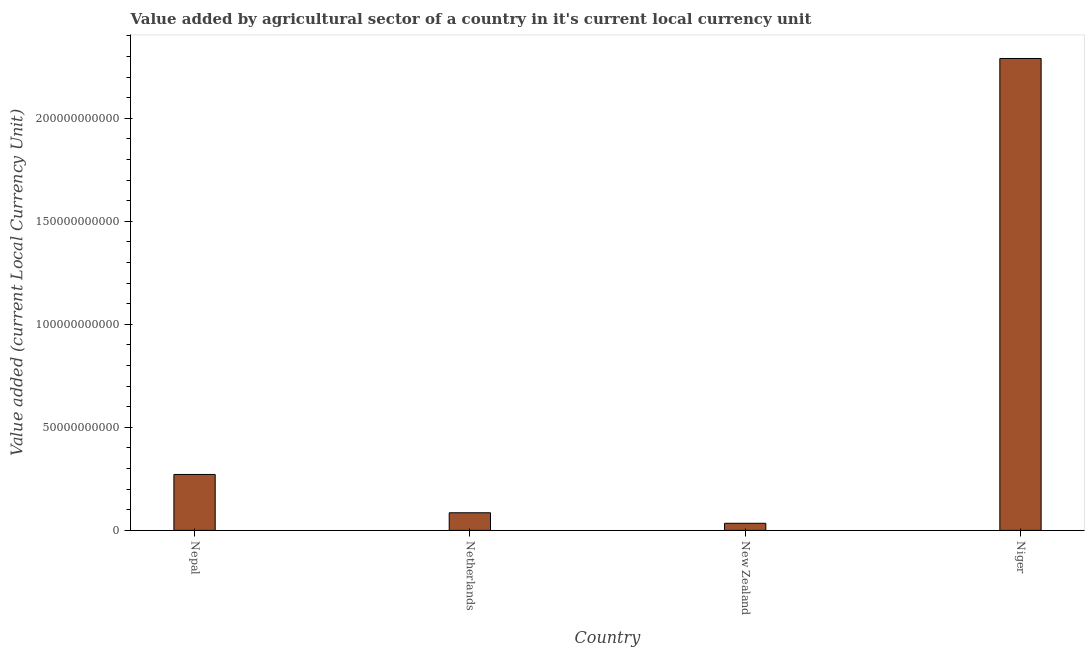Does the graph contain grids?
Offer a very short reply. No. What is the title of the graph?
Ensure brevity in your answer.  Value added by agricultural sector of a country in it's current local currency unit. What is the label or title of the Y-axis?
Provide a succinct answer. Value added (current Local Currency Unit). What is the value added by agriculture sector in Netherlands?
Offer a very short reply. 8.55e+09. Across all countries, what is the maximum value added by agriculture sector?
Provide a succinct answer. 2.29e+11. Across all countries, what is the minimum value added by agriculture sector?
Offer a very short reply. 3.45e+09. In which country was the value added by agriculture sector maximum?
Keep it short and to the point. Niger. In which country was the value added by agriculture sector minimum?
Your response must be concise. New Zealand. What is the sum of the value added by agriculture sector?
Provide a short and direct response. 2.68e+11. What is the difference between the value added by agriculture sector in Netherlands and Niger?
Provide a short and direct response. -2.20e+11. What is the average value added by agriculture sector per country?
Make the answer very short. 6.70e+1. What is the median value added by agriculture sector?
Provide a succinct answer. 1.78e+1. What is the ratio of the value added by agriculture sector in New Zealand to that in Niger?
Your answer should be compact. 0.01. Is the value added by agriculture sector in Nepal less than that in Niger?
Your answer should be very brief. Yes. Is the difference between the value added by agriculture sector in Netherlands and New Zealand greater than the difference between any two countries?
Provide a short and direct response. No. What is the difference between the highest and the second highest value added by agriculture sector?
Ensure brevity in your answer.  2.02e+11. What is the difference between the highest and the lowest value added by agriculture sector?
Your answer should be very brief. 2.26e+11. How many countries are there in the graph?
Provide a succinct answer. 4. What is the difference between two consecutive major ticks on the Y-axis?
Your answer should be very brief. 5.00e+1. Are the values on the major ticks of Y-axis written in scientific E-notation?
Provide a short and direct response. No. What is the Value added (current Local Currency Unit) of Nepal?
Offer a very short reply. 2.71e+1. What is the Value added (current Local Currency Unit) in Netherlands?
Your answer should be compact. 8.55e+09. What is the Value added (current Local Currency Unit) of New Zealand?
Your answer should be very brief. 3.45e+09. What is the Value added (current Local Currency Unit) in Niger?
Ensure brevity in your answer.  2.29e+11. What is the difference between the Value added (current Local Currency Unit) in Nepal and Netherlands?
Keep it short and to the point. 1.86e+1. What is the difference between the Value added (current Local Currency Unit) in Nepal and New Zealand?
Offer a very short reply. 2.37e+1. What is the difference between the Value added (current Local Currency Unit) in Nepal and Niger?
Provide a succinct answer. -2.02e+11. What is the difference between the Value added (current Local Currency Unit) in Netherlands and New Zealand?
Your answer should be compact. 5.10e+09. What is the difference between the Value added (current Local Currency Unit) in Netherlands and Niger?
Ensure brevity in your answer.  -2.20e+11. What is the difference between the Value added (current Local Currency Unit) in New Zealand and Niger?
Keep it short and to the point. -2.26e+11. What is the ratio of the Value added (current Local Currency Unit) in Nepal to that in Netherlands?
Keep it short and to the point. 3.17. What is the ratio of the Value added (current Local Currency Unit) in Nepal to that in New Zealand?
Provide a succinct answer. 7.87. What is the ratio of the Value added (current Local Currency Unit) in Nepal to that in Niger?
Provide a short and direct response. 0.12. What is the ratio of the Value added (current Local Currency Unit) in Netherlands to that in New Zealand?
Ensure brevity in your answer.  2.48. What is the ratio of the Value added (current Local Currency Unit) in Netherlands to that in Niger?
Give a very brief answer. 0.04. What is the ratio of the Value added (current Local Currency Unit) in New Zealand to that in Niger?
Provide a succinct answer. 0.01. 